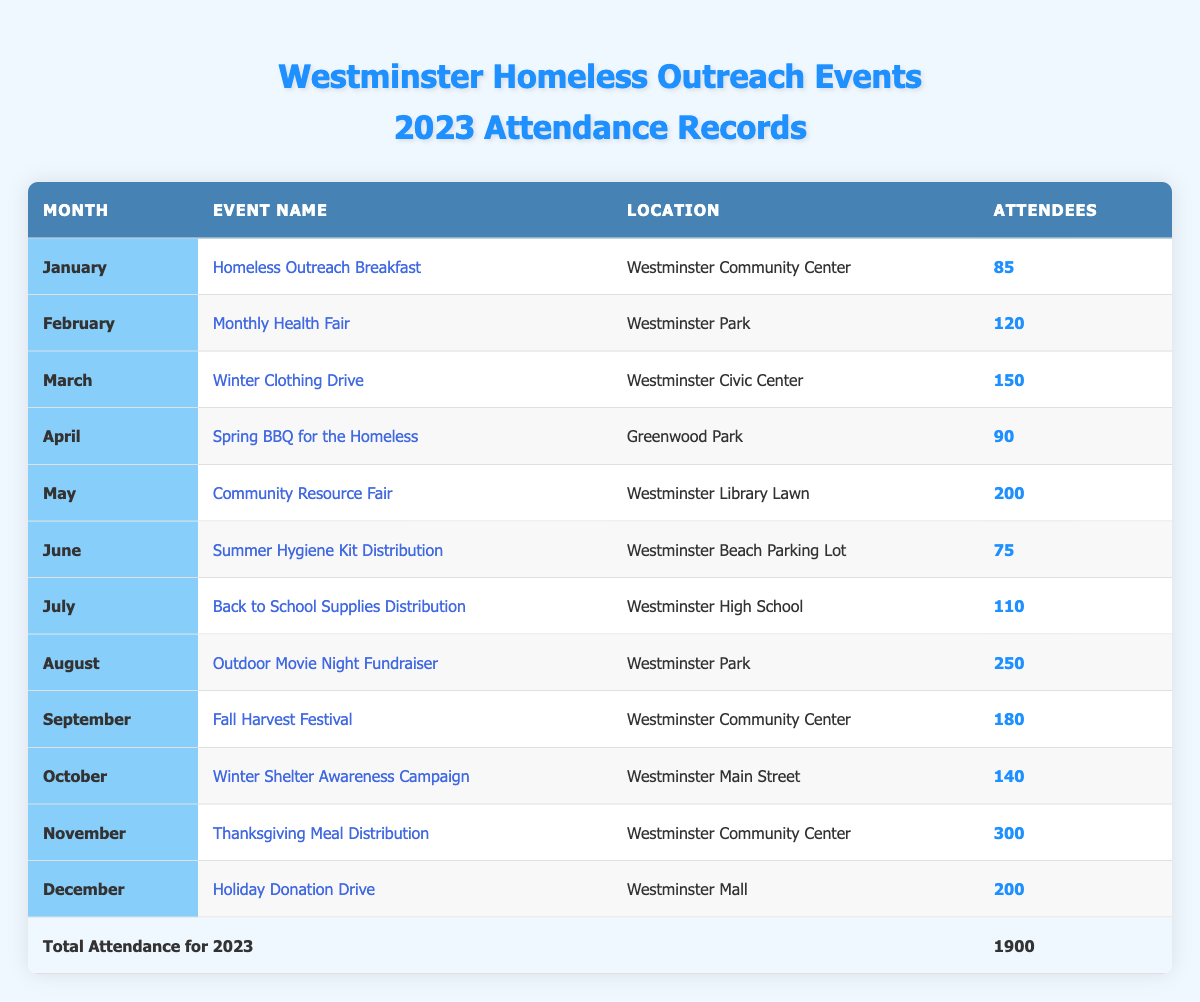What was the attendance at the Thanksgiving Meal Distribution event? The Thanksgiving Meal Distribution event took place in November 2023, and according to the table, it had an attendance of 300 people.
Answer: 300 Which event had the highest number of attendees in 2023? By examining the attendance figures in the table, the event with the highest attendance is the Thanksgiving Meal Distribution with 300 attendees.
Answer: Thanksgiving Meal Distribution What is the total number of attendees across all events in 2023? To find the total attendance, sum the attendees for each event: 85 + 120 + 150 + 90 + 200 + 75 + 110 + 250 + 180 + 140 + 300 + 200 = 1900.
Answer: 1900 Which month had the lowest attendance, and how many attendees were there? Looking at the table, June has the lowest number of attendees, with 75 participants for the Summer Hygiene Kit Distribution event.
Answer: June, 75 Is the attendance for the Winter Clothing Drive higher than that for the Spring BBQ for the Homeless? The Winter Clothing Drive had 150 attendees, while the Spring BBQ for the Homeless had 90. Since 150 is greater than 90, the statement is true.
Answer: Yes What is the average attendance of events held in the first half of the year (January to June)? The total attendance for the first half events is 85 + 120 + 150 + 90 + 200 + 75 = 720. There are 6 events, so the average is 720 / 6 = 120.
Answer: 120 How many more attendees were at the Outdoor Movie Night Fundraiser compared to the Summer Hygiene Kit Distribution? The Outdoor Movie Night Fundraiser had 250 attendees, and the Summer Hygiene Kit Distribution had 75 attendees. The difference is 250 - 75 = 175.
Answer: 175 Which event took place in September, and how many attendees did it have? The Fall Harvest Festival took place in September 2023, which had 180 attendees according to the table.
Answer: Fall Harvest Festival, 180 Between which two months was the highest increase in attendance, and what was that increase? The highest increase in attendance was between October (140 attendees) and November (300 attendees) with an increase of 300 - 140 = 160.
Answer: October to November, 160 What percentage of total attendance does the Community Resource Fair represent? The Community Resource Fair had 200 attendees; to find the percentage, divide 200 by the total attendance of 1900, then multiply by 100: (200 / 1900) * 100 = 10.53%.
Answer: 10.53% 